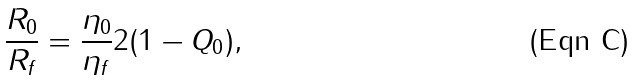Convert formula to latex. <formula><loc_0><loc_0><loc_500><loc_500>\frac { R _ { 0 } } { R _ { f } } = \frac { \eta _ { 0 } } { \eta _ { f } } 2 ( 1 - Q _ { 0 } ) ,</formula> 